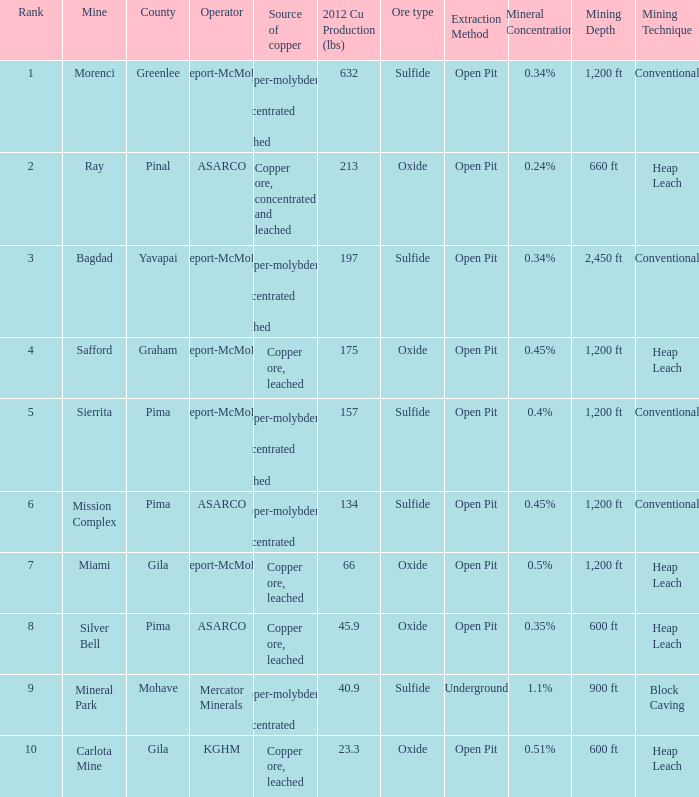What's the lowest ranking source of copper, copper ore, concentrated and leached? 2.0. 